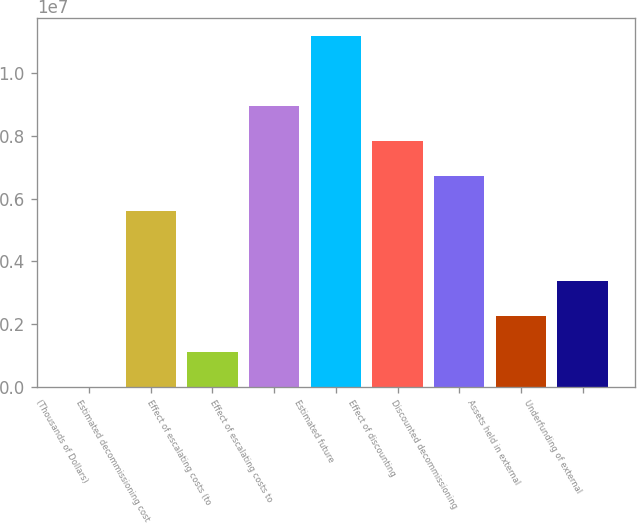<chart> <loc_0><loc_0><loc_500><loc_500><bar_chart><fcel>(Thousands of Dollars)<fcel>Estimated decommissioning cost<fcel>Effect of escalating costs (to<fcel>Effect of escalating costs to<fcel>Estimated future<fcel>Effect of discounting<fcel>Discounted decommissioning<fcel>Assets held in external<fcel>Underfunding of external<nl><fcel>2015<fcel>5.60375e+06<fcel>1.12236e+06<fcel>8.9648e+06<fcel>1.12055e+07<fcel>7.84445e+06<fcel>6.7241e+06<fcel>2.24271e+06<fcel>3.36306e+06<nl></chart> 